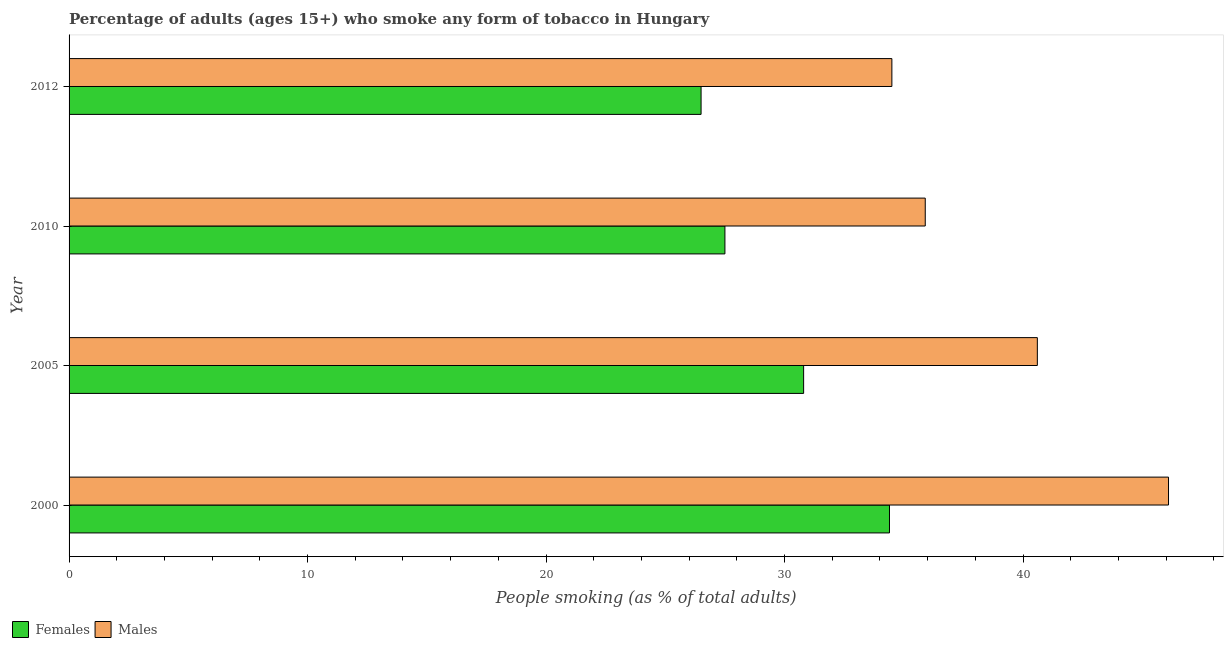How many groups of bars are there?
Offer a terse response. 4. What is the label of the 2nd group of bars from the top?
Your answer should be compact. 2010. What is the percentage of females who smoke in 2005?
Provide a short and direct response. 30.8. Across all years, what is the maximum percentage of males who smoke?
Ensure brevity in your answer.  46.1. Across all years, what is the minimum percentage of females who smoke?
Your answer should be very brief. 26.5. In which year was the percentage of females who smoke minimum?
Provide a short and direct response. 2012. What is the total percentage of males who smoke in the graph?
Provide a succinct answer. 157.1. What is the difference between the percentage of males who smoke in 2010 and the percentage of females who smoke in 2005?
Offer a very short reply. 5.1. What is the average percentage of males who smoke per year?
Keep it short and to the point. 39.27. In the year 2005, what is the difference between the percentage of males who smoke and percentage of females who smoke?
Your answer should be very brief. 9.8. What is the ratio of the percentage of males who smoke in 2005 to that in 2012?
Offer a very short reply. 1.18. Is the difference between the percentage of males who smoke in 2005 and 2012 greater than the difference between the percentage of females who smoke in 2005 and 2012?
Ensure brevity in your answer.  Yes. What is the difference between the highest and the lowest percentage of males who smoke?
Provide a short and direct response. 11.6. In how many years, is the percentage of females who smoke greater than the average percentage of females who smoke taken over all years?
Give a very brief answer. 2. What does the 1st bar from the top in 2000 represents?
Provide a succinct answer. Males. What does the 1st bar from the bottom in 2012 represents?
Give a very brief answer. Females. How many bars are there?
Your response must be concise. 8. Are all the bars in the graph horizontal?
Your answer should be compact. Yes. What is the difference between two consecutive major ticks on the X-axis?
Your response must be concise. 10. Where does the legend appear in the graph?
Offer a very short reply. Bottom left. How many legend labels are there?
Ensure brevity in your answer.  2. What is the title of the graph?
Ensure brevity in your answer.  Percentage of adults (ages 15+) who smoke any form of tobacco in Hungary. Does "Exports of goods" appear as one of the legend labels in the graph?
Your answer should be compact. No. What is the label or title of the X-axis?
Provide a short and direct response. People smoking (as % of total adults). What is the label or title of the Y-axis?
Offer a terse response. Year. What is the People smoking (as % of total adults) of Females in 2000?
Make the answer very short. 34.4. What is the People smoking (as % of total adults) in Males in 2000?
Your answer should be compact. 46.1. What is the People smoking (as % of total adults) in Females in 2005?
Offer a terse response. 30.8. What is the People smoking (as % of total adults) of Males in 2005?
Keep it short and to the point. 40.6. What is the People smoking (as % of total adults) in Females in 2010?
Make the answer very short. 27.5. What is the People smoking (as % of total adults) of Males in 2010?
Ensure brevity in your answer.  35.9. What is the People smoking (as % of total adults) of Females in 2012?
Offer a terse response. 26.5. What is the People smoking (as % of total adults) in Males in 2012?
Your answer should be compact. 34.5. Across all years, what is the maximum People smoking (as % of total adults) of Females?
Ensure brevity in your answer.  34.4. Across all years, what is the maximum People smoking (as % of total adults) in Males?
Provide a succinct answer. 46.1. Across all years, what is the minimum People smoking (as % of total adults) of Females?
Ensure brevity in your answer.  26.5. Across all years, what is the minimum People smoking (as % of total adults) of Males?
Provide a short and direct response. 34.5. What is the total People smoking (as % of total adults) of Females in the graph?
Give a very brief answer. 119.2. What is the total People smoking (as % of total adults) of Males in the graph?
Keep it short and to the point. 157.1. What is the difference between the People smoking (as % of total adults) in Females in 2000 and that in 2005?
Offer a terse response. 3.6. What is the difference between the People smoking (as % of total adults) of Females in 2000 and that in 2010?
Your answer should be compact. 6.9. What is the difference between the People smoking (as % of total adults) of Males in 2000 and that in 2010?
Offer a very short reply. 10.2. What is the difference between the People smoking (as % of total adults) in Males in 2000 and that in 2012?
Provide a short and direct response. 11.6. What is the difference between the People smoking (as % of total adults) of Females in 2005 and that in 2010?
Give a very brief answer. 3.3. What is the difference between the People smoking (as % of total adults) of Males in 2005 and that in 2010?
Make the answer very short. 4.7. What is the difference between the People smoking (as % of total adults) of Males in 2005 and that in 2012?
Give a very brief answer. 6.1. What is the difference between the People smoking (as % of total adults) of Females in 2000 and the People smoking (as % of total adults) of Males in 2005?
Provide a succinct answer. -6.2. What is the difference between the People smoking (as % of total adults) of Females in 2000 and the People smoking (as % of total adults) of Males in 2010?
Your answer should be compact. -1.5. What is the difference between the People smoking (as % of total adults) of Females in 2000 and the People smoking (as % of total adults) of Males in 2012?
Offer a terse response. -0.1. What is the difference between the People smoking (as % of total adults) of Females in 2005 and the People smoking (as % of total adults) of Males in 2010?
Your response must be concise. -5.1. What is the difference between the People smoking (as % of total adults) in Females in 2005 and the People smoking (as % of total adults) in Males in 2012?
Keep it short and to the point. -3.7. What is the average People smoking (as % of total adults) of Females per year?
Keep it short and to the point. 29.8. What is the average People smoking (as % of total adults) of Males per year?
Your answer should be very brief. 39.27. In the year 2000, what is the difference between the People smoking (as % of total adults) of Females and People smoking (as % of total adults) of Males?
Offer a terse response. -11.7. In the year 2005, what is the difference between the People smoking (as % of total adults) in Females and People smoking (as % of total adults) in Males?
Make the answer very short. -9.8. What is the ratio of the People smoking (as % of total adults) in Females in 2000 to that in 2005?
Offer a terse response. 1.12. What is the ratio of the People smoking (as % of total adults) in Males in 2000 to that in 2005?
Keep it short and to the point. 1.14. What is the ratio of the People smoking (as % of total adults) in Females in 2000 to that in 2010?
Ensure brevity in your answer.  1.25. What is the ratio of the People smoking (as % of total adults) of Males in 2000 to that in 2010?
Provide a short and direct response. 1.28. What is the ratio of the People smoking (as % of total adults) of Females in 2000 to that in 2012?
Provide a short and direct response. 1.3. What is the ratio of the People smoking (as % of total adults) of Males in 2000 to that in 2012?
Your response must be concise. 1.34. What is the ratio of the People smoking (as % of total adults) in Females in 2005 to that in 2010?
Your answer should be very brief. 1.12. What is the ratio of the People smoking (as % of total adults) of Males in 2005 to that in 2010?
Provide a succinct answer. 1.13. What is the ratio of the People smoking (as % of total adults) in Females in 2005 to that in 2012?
Give a very brief answer. 1.16. What is the ratio of the People smoking (as % of total adults) in Males in 2005 to that in 2012?
Your response must be concise. 1.18. What is the ratio of the People smoking (as % of total adults) in Females in 2010 to that in 2012?
Offer a very short reply. 1.04. What is the ratio of the People smoking (as % of total adults) of Males in 2010 to that in 2012?
Provide a short and direct response. 1.04. What is the difference between the highest and the second highest People smoking (as % of total adults) in Males?
Give a very brief answer. 5.5. What is the difference between the highest and the lowest People smoking (as % of total adults) in Males?
Offer a terse response. 11.6. 